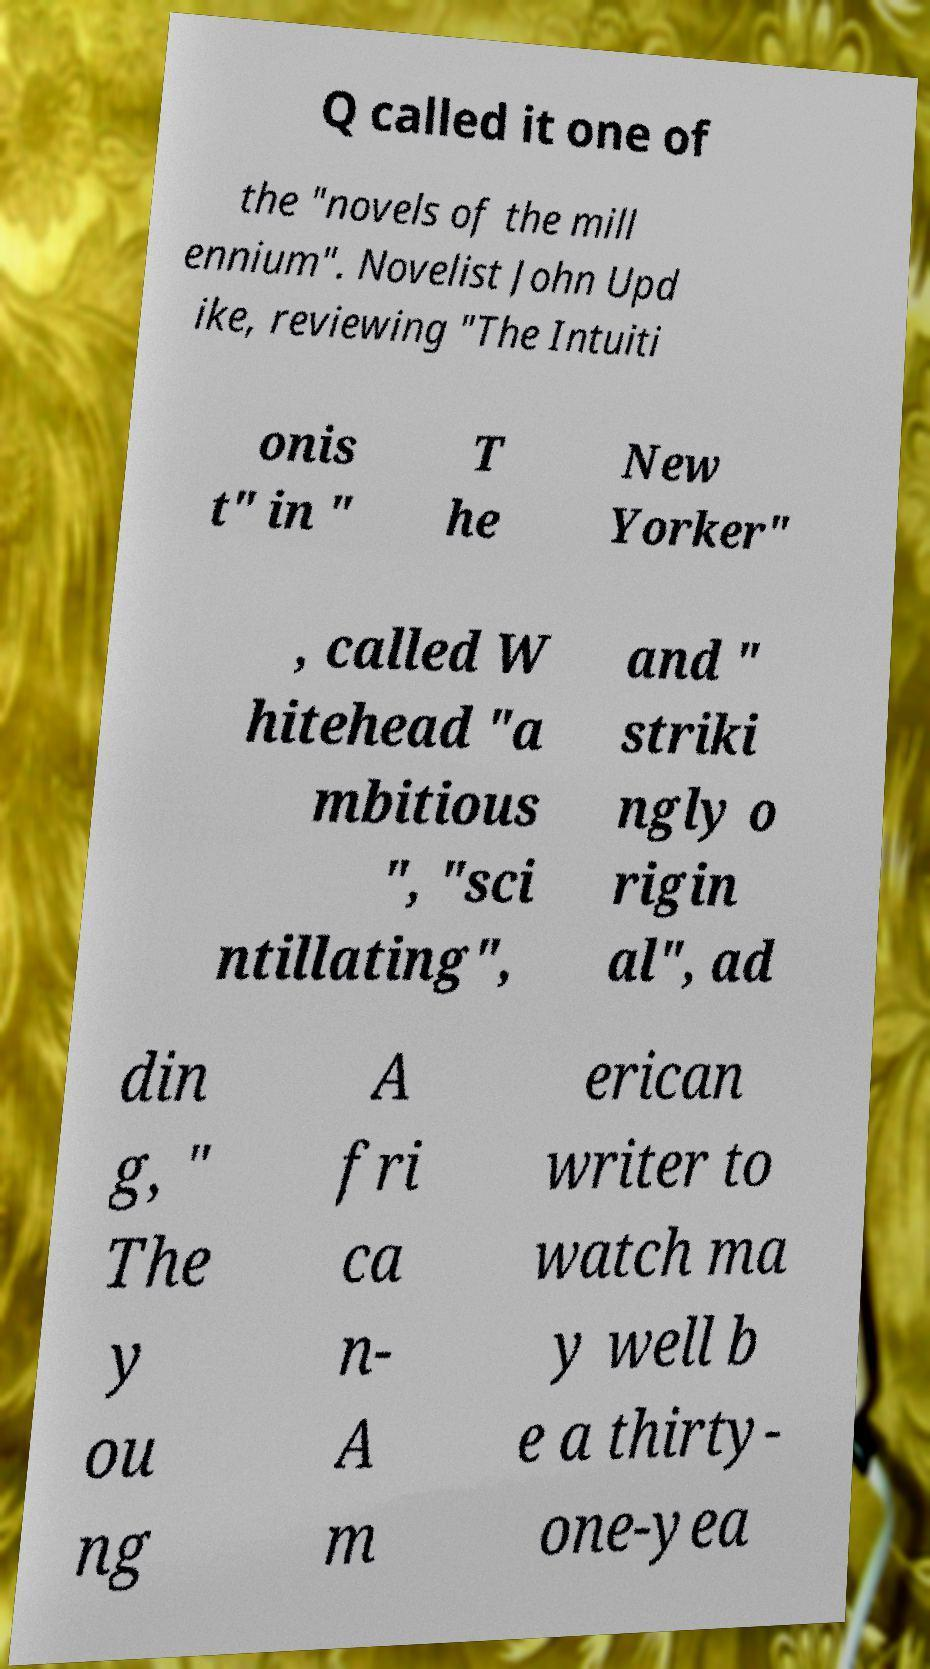Please read and relay the text visible in this image. What does it say? Q called it one of the "novels of the mill ennium". Novelist John Upd ike, reviewing "The Intuiti onis t" in " T he New Yorker" , called W hitehead "a mbitious ", "sci ntillating", and " striki ngly o rigin al", ad din g, " The y ou ng A fri ca n- A m erican writer to watch ma y well b e a thirty- one-yea 